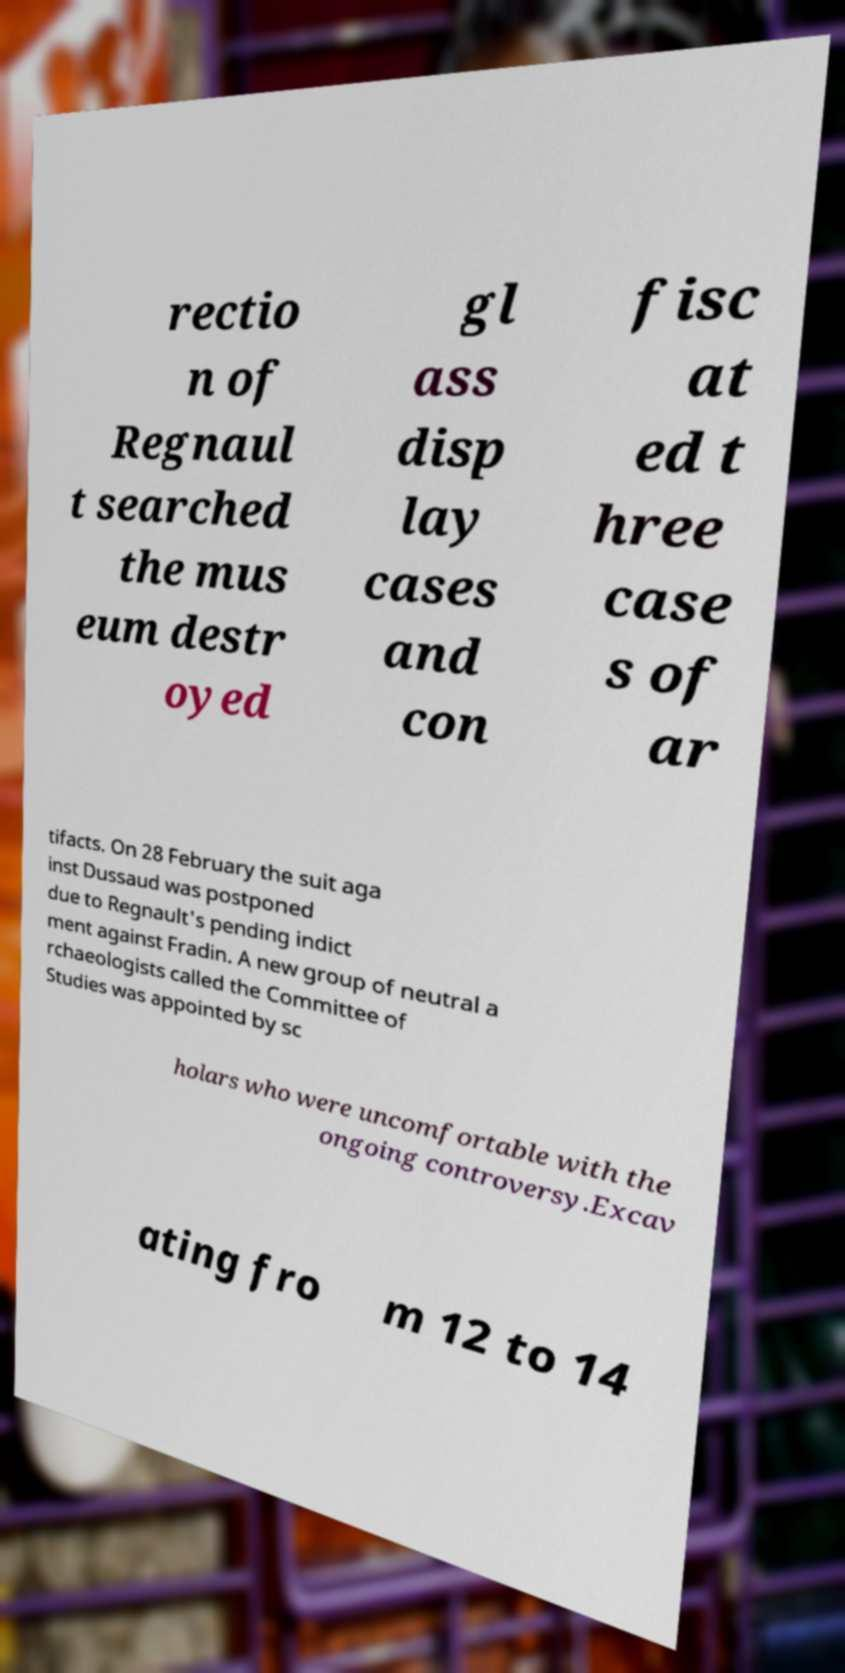Can you read and provide the text displayed in the image?This photo seems to have some interesting text. Can you extract and type it out for me? rectio n of Regnaul t searched the mus eum destr oyed gl ass disp lay cases and con fisc at ed t hree case s of ar tifacts. On 28 February the suit aga inst Dussaud was postponed due to Regnault's pending indict ment against Fradin. A new group of neutral a rchaeologists called the Committee of Studies was appointed by sc holars who were uncomfortable with the ongoing controversy.Excav ating fro m 12 to 14 